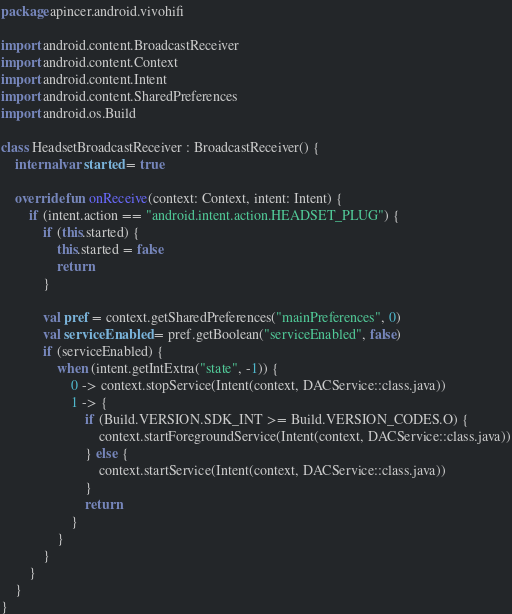Convert code to text. <code><loc_0><loc_0><loc_500><loc_500><_Kotlin_>package apincer.android.vivohifi

import android.content.BroadcastReceiver
import android.content.Context
import android.content.Intent
import android.content.SharedPreferences
import android.os.Build

class HeadsetBroadcastReceiver : BroadcastReceiver() {
    internal var started = true

    override fun onReceive(context: Context, intent: Intent) {
        if (intent.action == "android.intent.action.HEADSET_PLUG") {
            if (this.started) {
                this.started = false
                return
            }

            val pref = context.getSharedPreferences("mainPreferences", 0)
            val serviceEnabled = pref.getBoolean("serviceEnabled", false)
            if (serviceEnabled) {
                when (intent.getIntExtra("state", -1)) {
                    0 -> context.stopService(Intent(context, DACService::class.java))
                    1 -> {
                        if (Build.VERSION.SDK_INT >= Build.VERSION_CODES.O) {
                            context.startForegroundService(Intent(context, DACService::class.java))
                        } else {
                            context.startService(Intent(context, DACService::class.java))
                        }
                        return
                    }
                }
            }
        }
    }
}
</code> 